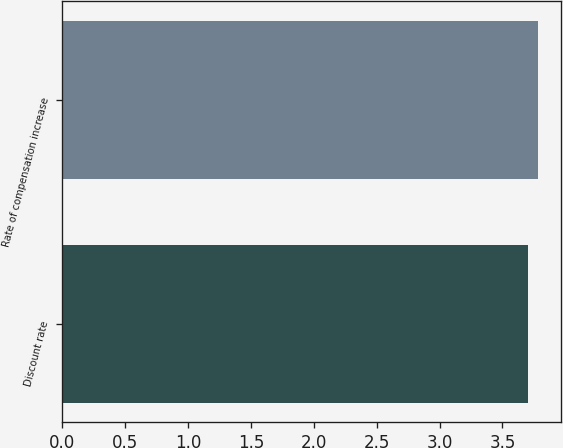<chart> <loc_0><loc_0><loc_500><loc_500><bar_chart><fcel>Discount rate<fcel>Rate of compensation increase<nl><fcel>3.7<fcel>3.78<nl></chart> 